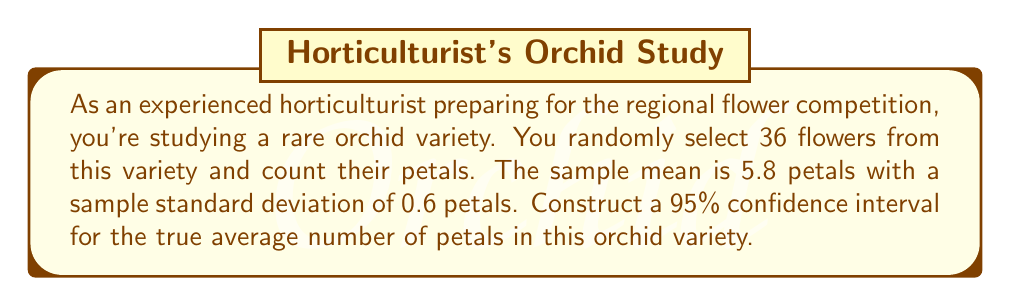Teach me how to tackle this problem. Let's construct the confidence interval step by step:

1) The formula for a confidence interval is:

   $$\bar{x} \pm t_{\alpha/2} \cdot \frac{s}{\sqrt{n}}$$

   where $\bar{x}$ is the sample mean, $s$ is the sample standard deviation, $n$ is the sample size, and $t_{\alpha/2}$ is the t-value for the desired confidence level.

2) We're given:
   $\bar{x} = 5.8$
   $s = 0.6$
   $n = 36$
   Confidence level = 95% (so $\alpha = 0.05$)

3) For a 95% confidence interval with 35 degrees of freedom (n - 1 = 35), the t-value is approximately 2.030.

4) Now, let's calculate the margin of error:

   $$t_{\alpha/2} \cdot \frac{s}{\sqrt{n}} = 2.030 \cdot \frac{0.6}{\sqrt{36}} = 2.030 \cdot 0.1 = 0.203$$

5) Therefore, the confidence interval is:

   $$5.8 \pm 0.203$$

6) This gives us the interval:

   $$5.8 - 0.203 \text{ to } 5.8 + 0.203$$
   $$5.597 \text{ to } 6.003$$

7) Rounding to two decimal places:

   $$5.60 \text{ to } 6.00$$
Answer: (5.60, 6.00) 